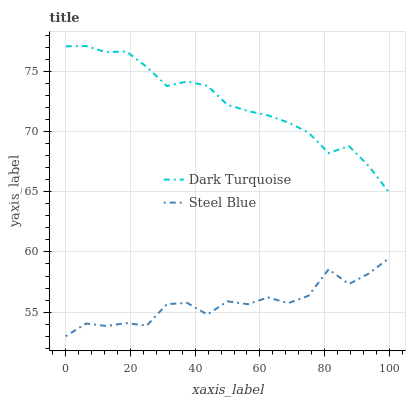Does Steel Blue have the minimum area under the curve?
Answer yes or no. Yes. Does Dark Turquoise have the maximum area under the curve?
Answer yes or no. Yes. Does Steel Blue have the maximum area under the curve?
Answer yes or no. No. Is Dark Turquoise the smoothest?
Answer yes or no. Yes. Is Steel Blue the roughest?
Answer yes or no. Yes. Is Steel Blue the smoothest?
Answer yes or no. No. Does Dark Turquoise have the highest value?
Answer yes or no. Yes. Does Steel Blue have the highest value?
Answer yes or no. No. Is Steel Blue less than Dark Turquoise?
Answer yes or no. Yes. Is Dark Turquoise greater than Steel Blue?
Answer yes or no. Yes. Does Steel Blue intersect Dark Turquoise?
Answer yes or no. No. 